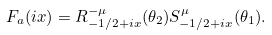Convert formula to latex. <formula><loc_0><loc_0><loc_500><loc_500>F _ { a } ( i x ) = R ^ { - \mu } _ { - 1 / 2 + i x } ( \theta _ { 2 } ) S ^ { \mu } _ { - 1 / 2 + i x } ( \theta _ { 1 } ) .</formula> 